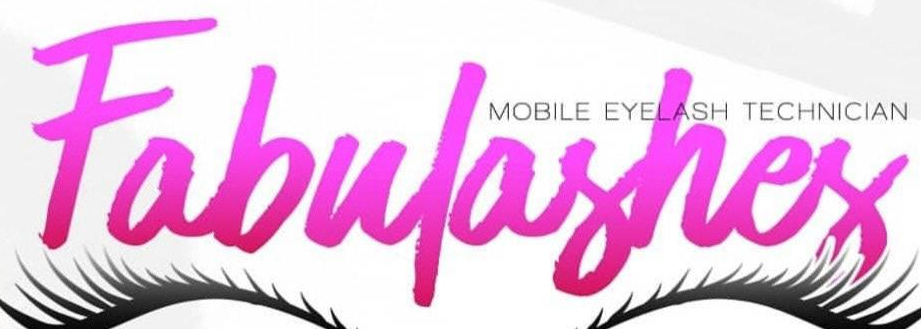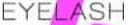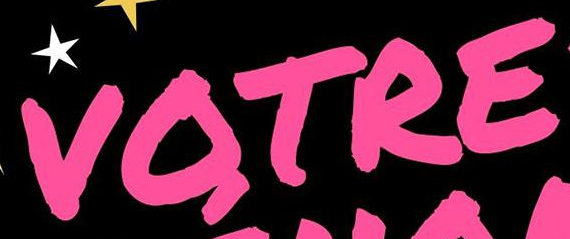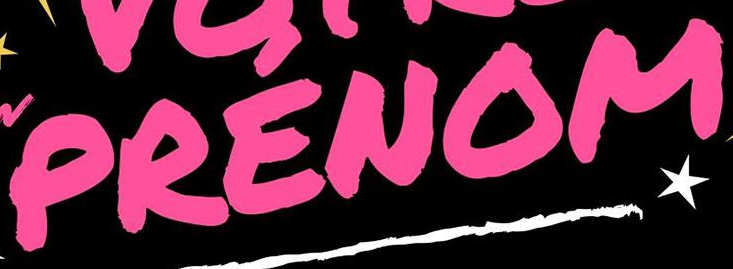What text is displayed in these images sequentially, separated by a semicolon? Fabulashes; EYELASH; VOTRE; PRENOM 